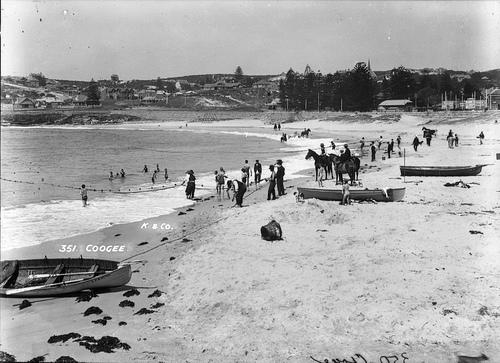Is this in the city?
Write a very short answer. No. What vehicle is closest to the camera?
Give a very brief answer. Boat. Is anyone in the nearest boat?
Short answer required. No. What color is the photo in?
Answer briefly. Black and white. Are there horses on the beach?
Quick response, please. Yes. What are the boats in?
Give a very brief answer. Sand. 